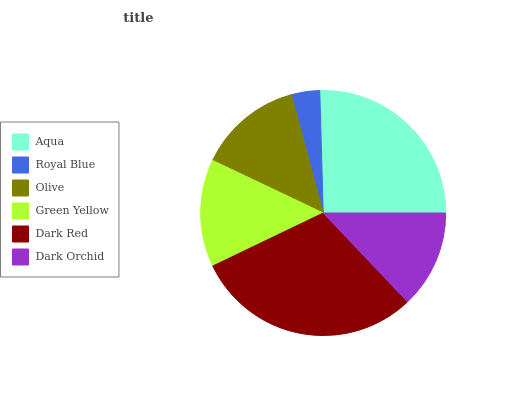Is Royal Blue the minimum?
Answer yes or no. Yes. Is Dark Red the maximum?
Answer yes or no. Yes. Is Olive the minimum?
Answer yes or no. No. Is Olive the maximum?
Answer yes or no. No. Is Olive greater than Royal Blue?
Answer yes or no. Yes. Is Royal Blue less than Olive?
Answer yes or no. Yes. Is Royal Blue greater than Olive?
Answer yes or no. No. Is Olive less than Royal Blue?
Answer yes or no. No. Is Green Yellow the high median?
Answer yes or no. Yes. Is Olive the low median?
Answer yes or no. Yes. Is Aqua the high median?
Answer yes or no. No. Is Aqua the low median?
Answer yes or no. No. 